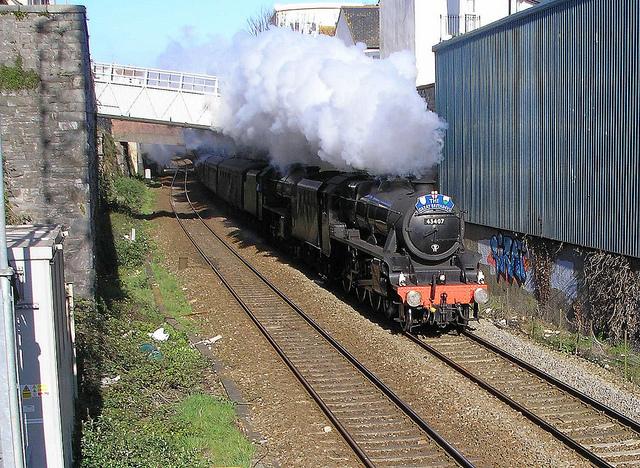Is the train removing smoke?
Concise answer only. No. Is this a new train?
Short answer required. No. How many train tracks are in this picture?
Quick response, please. 2. 